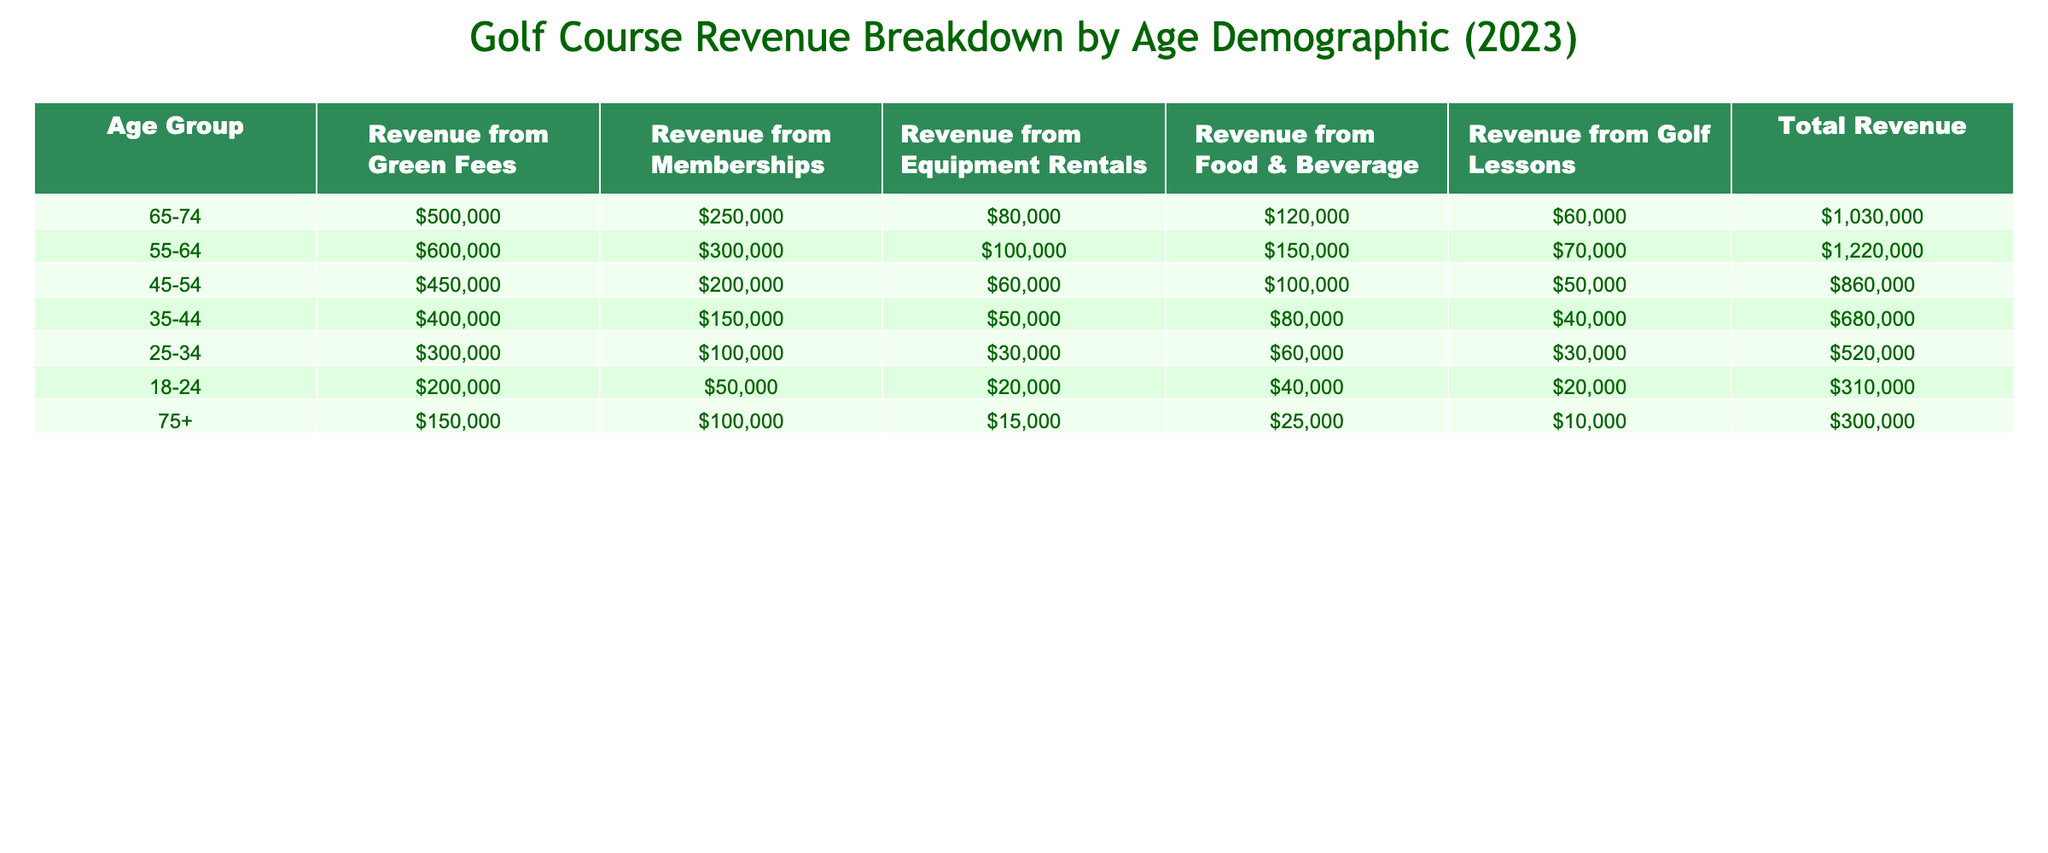what is the total revenue generated from the 65-74 age group? From the table, the total revenue for the 65-74 age group is provided in the last column, and it shows a value of 1,030,000.
Answer: 1,030,000 which age group generated the highest revenue from food and beverage? By examining the food and beverage revenue for each age group, the 55-64 age group has the highest amount at 150,000.
Answer: 55-64 what is the revenue from memberships for the 25-34 age group? The revenue from memberships for the 25-34 age group is directly listed in the table as 100,000.
Answer: 100,000 how much more revenue was generated from green fees by the 55-64 age group compared to the 75+ age group? The revenue from green fees for the 55-64 age group is 600,000 and for the 75+ age group it is 150,000. The difference is calculated as 600,000 - 150,000 = 450,000.
Answer: 450,000 what is the total revenue from equipment rentals across all age groups? To find the total revenue from equipment rentals, sum the individual revenues from each age group. The calculations: 80,000 + 100,000 + 60,000 + 50,000 + 30,000 + 20,000 + 15,000 = 355,000.
Answer: 355,000 which age group contributed the least to the total revenue? By looking at the total revenue for each age group, the 75+ age group has the lowest total at 300,000, making it the least contributing group.
Answer: 75+ what percentage of the total revenue was generated from golf lessons by the 45-54 age group? For the 45-54 age group, the revenue from golf lessons is 50,000 and the total revenue is 860,000. The percentage is calculated as (50,000 / 860,000) * 100 = 5.81%.
Answer: 5.81% what is the combined revenue from green fees and food & beverage for the 35-44 age group? The revenue from green fees for the 35-44 age group is 400,000 and from food & beverage is 80,000. Combined, this is 400,000 + 80,000 = 480,000.
Answer: 480,000 is it true that the revenue from golf lessons increases with age? Analyzing the golf lesson revenues across each age group: 60,000 (65-74), 70,000 (55-64), 50,000 (45-54), 40,000 (35-44), 30,000 (25-34), 20,000 (18-24), and 10,000 (75+), it shows a decline as age increases after 55. Therefore, the statement is false.
Answer: False if we consider the age groups collectively, what is the average revenue from memberships? To find this, add the membership revenues (250,000 + 300,000 + 200,000 + 150,000 + 100,000 + 50,000 + 100,000) = 1,150,000. Then divide by the number of groups, which is 7. The average is 1,150,000 / 7 ≈ 164,286.
Answer: 164,286 